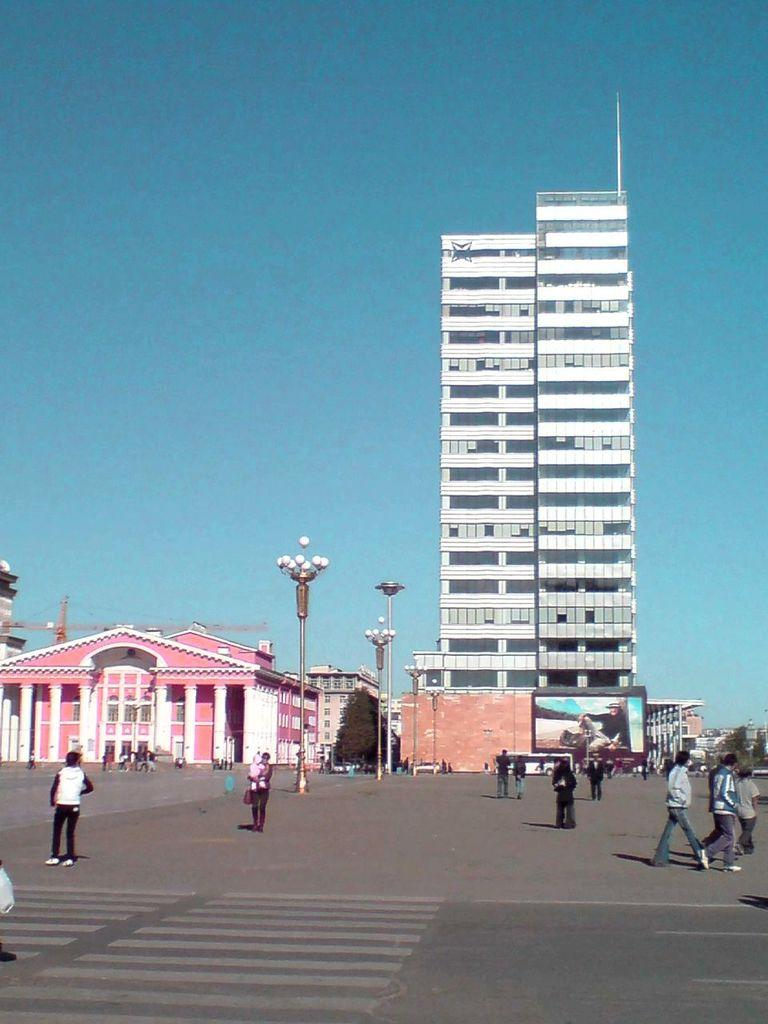Who or what can be seen in the image? There are people in the image. What can be seen in the background of the image? There are buildings with windows, trees, a hoarding, and light poles visible in the background. What is the color of the sky in the image? The sky is blue in color. What type of root can be seen growing from the people in the image? There are no roots visible in the image; it features people and various background elements. What holiday is being celebrated in the image? There is no indication of a holiday being celebrated in the image. 